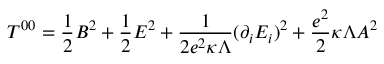<formula> <loc_0><loc_0><loc_500><loc_500>T ^ { 0 0 } = \frac { 1 } { 2 } B ^ { 2 } + \frac { 1 } { 2 } E ^ { 2 } + \frac { 1 } { 2 e ^ { 2 } \kappa \Lambda } ( \partial _ { i } E _ { i } ) ^ { 2 } + \frac { e ^ { 2 } } { 2 } \kappa \Lambda A ^ { 2 }</formula> 